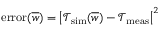Convert formula to latex. <formula><loc_0><loc_0><loc_500><loc_500>e r r o r ( \overline { w } ) = \left | \mathcal { T } _ { s i m } ( \overline { w } ) - \mathcal { T } _ { m e a s } \right | ^ { 2 }</formula> 